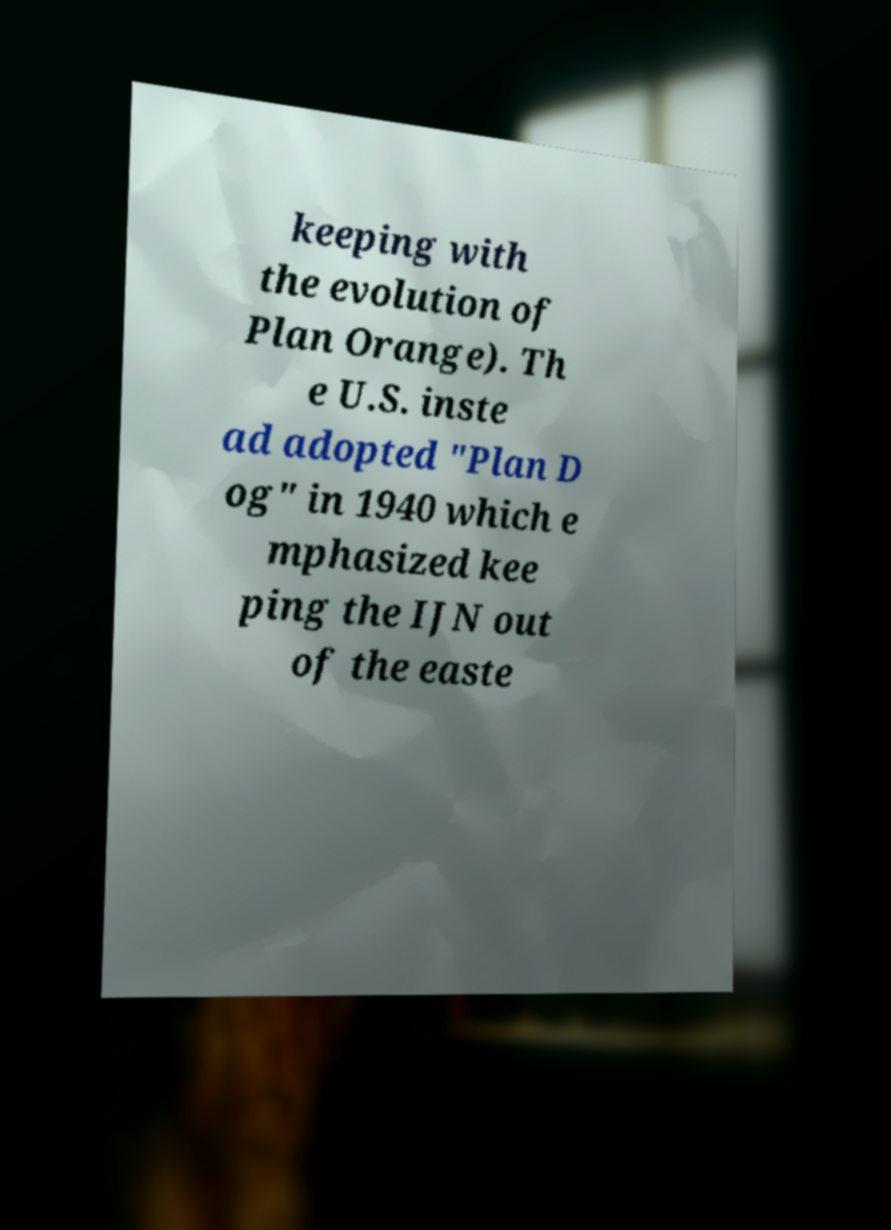I need the written content from this picture converted into text. Can you do that? keeping with the evolution of Plan Orange). Th e U.S. inste ad adopted "Plan D og" in 1940 which e mphasized kee ping the IJN out of the easte 